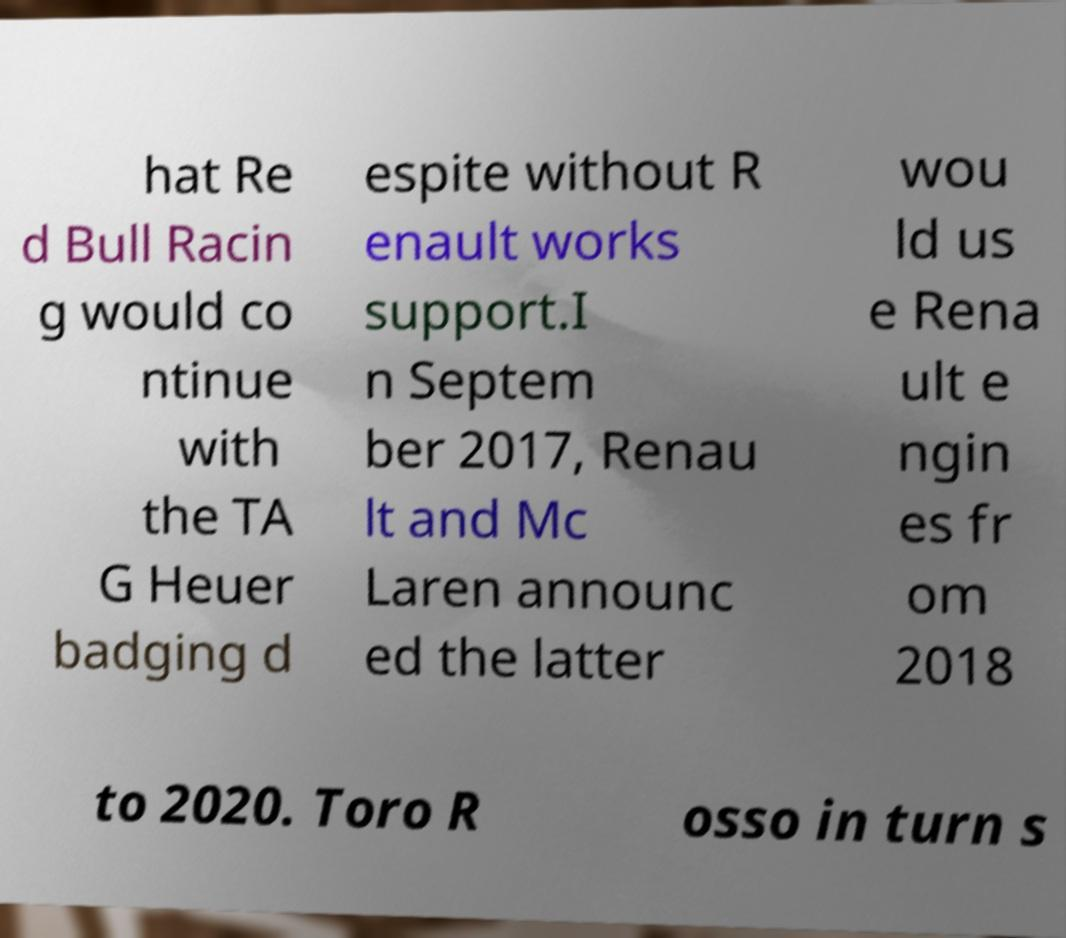I need the written content from this picture converted into text. Can you do that? hat Re d Bull Racin g would co ntinue with the TA G Heuer badging d espite without R enault works support.I n Septem ber 2017, Renau lt and Mc Laren announc ed the latter wou ld us e Rena ult e ngin es fr om 2018 to 2020. Toro R osso in turn s 